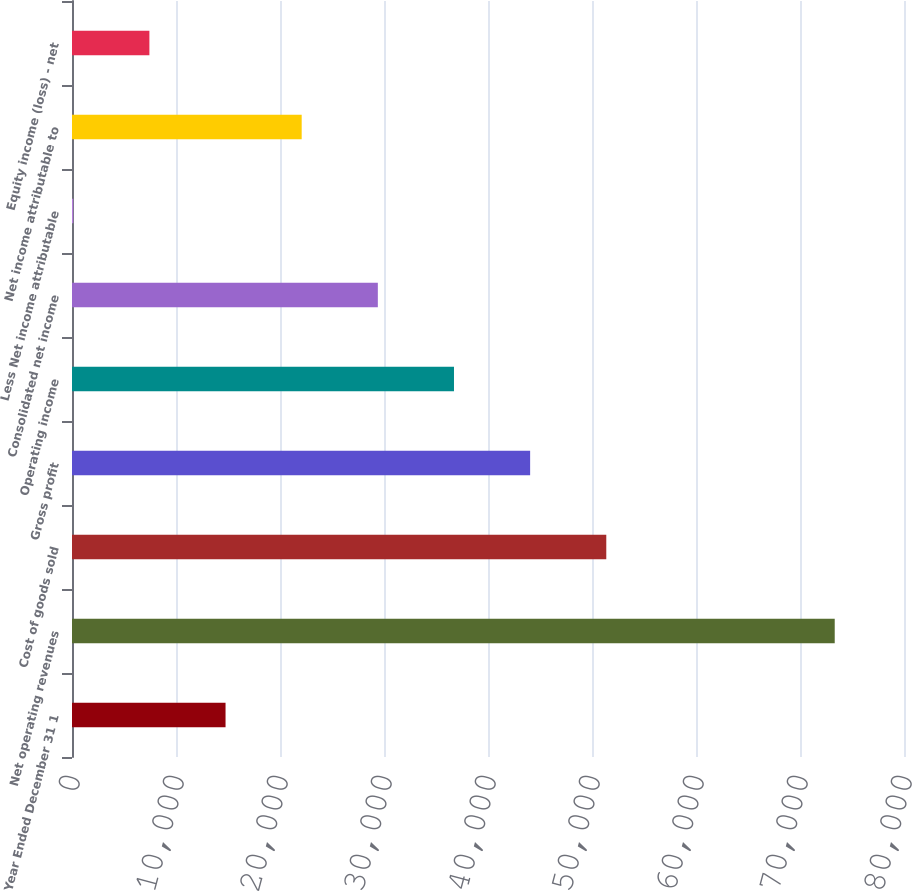Convert chart. <chart><loc_0><loc_0><loc_500><loc_500><bar_chart><fcel>Year Ended December 31 1<fcel>Net operating revenues<fcel>Cost of goods sold<fcel>Gross profit<fcel>Operating income<fcel>Consolidated net income<fcel>Less Net income attributable<fcel>Net income attributable to<fcel>Equity income (loss) - net<nl><fcel>14763.8<fcel>73339<fcel>51373.3<fcel>44051.4<fcel>36729.5<fcel>29407.6<fcel>120<fcel>22085.7<fcel>7441.9<nl></chart> 